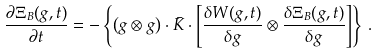Convert formula to latex. <formula><loc_0><loc_0><loc_500><loc_500>\frac { \partial \Xi _ { B } ( g , t ) } { \partial t } = - \left \{ \left ( g \otimes g \right ) \cdot \bar { K } \cdot \left [ \frac { \delta W ( g , t ) } { \delta g } \otimes \frac { \delta \Xi _ { B } ( g , t ) } { \delta g } \right ] \right \} \, .</formula> 